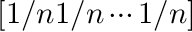<formula> <loc_0><loc_0><loc_500><loc_500>[ 1 / n 1 / n \cdots 1 / n ]</formula> 